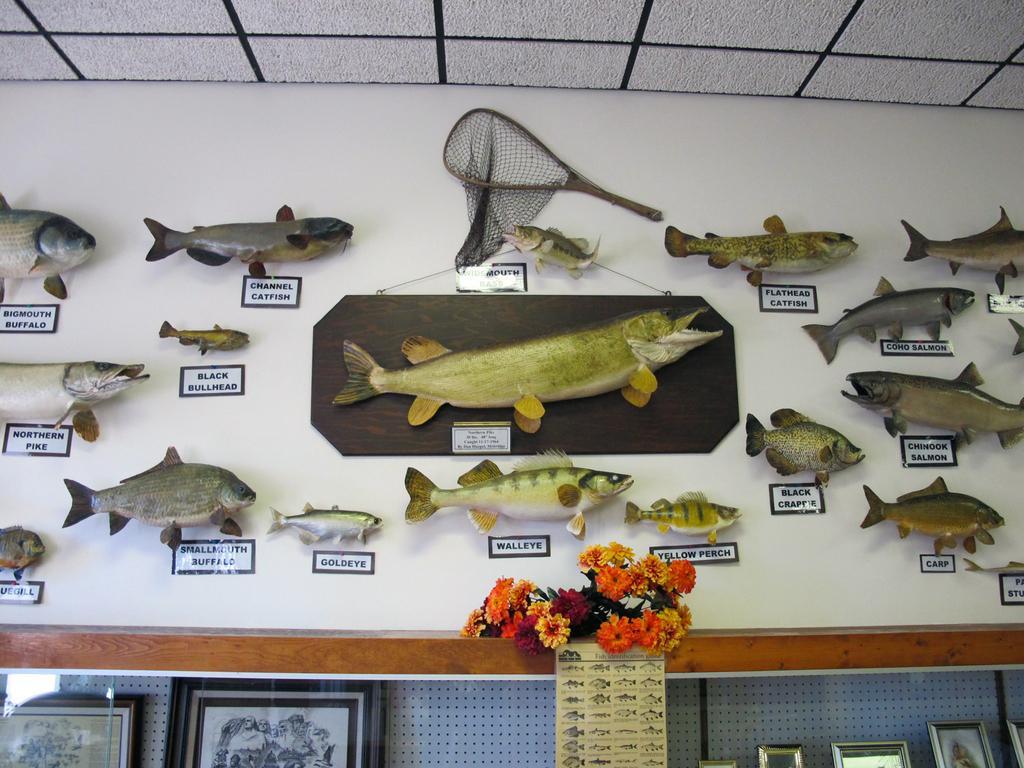Could you give a brief overview of what you see in this image? In this picture we can see a wall and on the wall there are sculptures of fishes, net and name boards. In front of the wall there are flowers, photo frames and a photo. v 